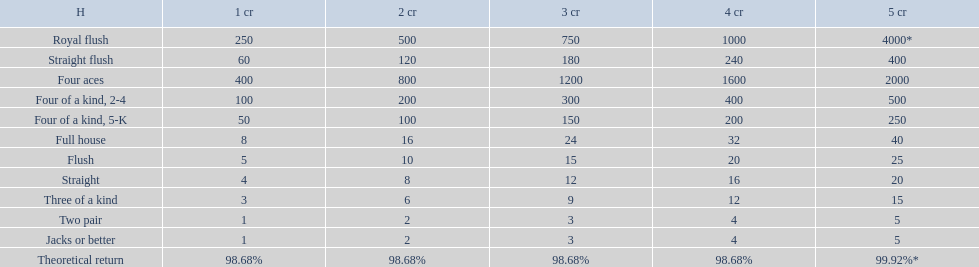What are the hands? Royal flush, Straight flush, Four aces, Four of a kind, 2-4, Four of a kind, 5-K, Full house, Flush, Straight, Three of a kind, Two pair, Jacks or better. Which hand is on the top? Royal flush. 